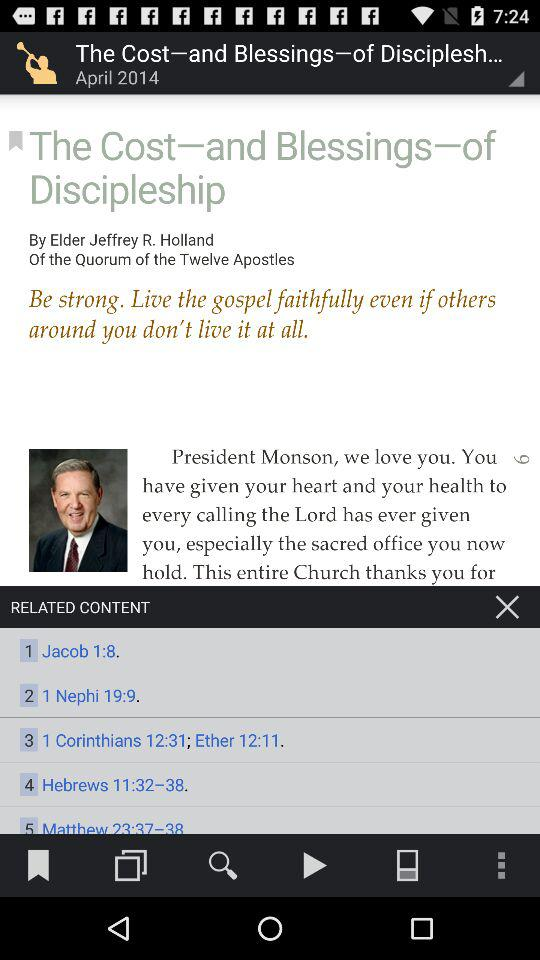Who is a member of the "Quorum of the Twelve Apostles"? A member of the "Quorum of the Twelve Apostles" is Jeffrey R. Holland. 